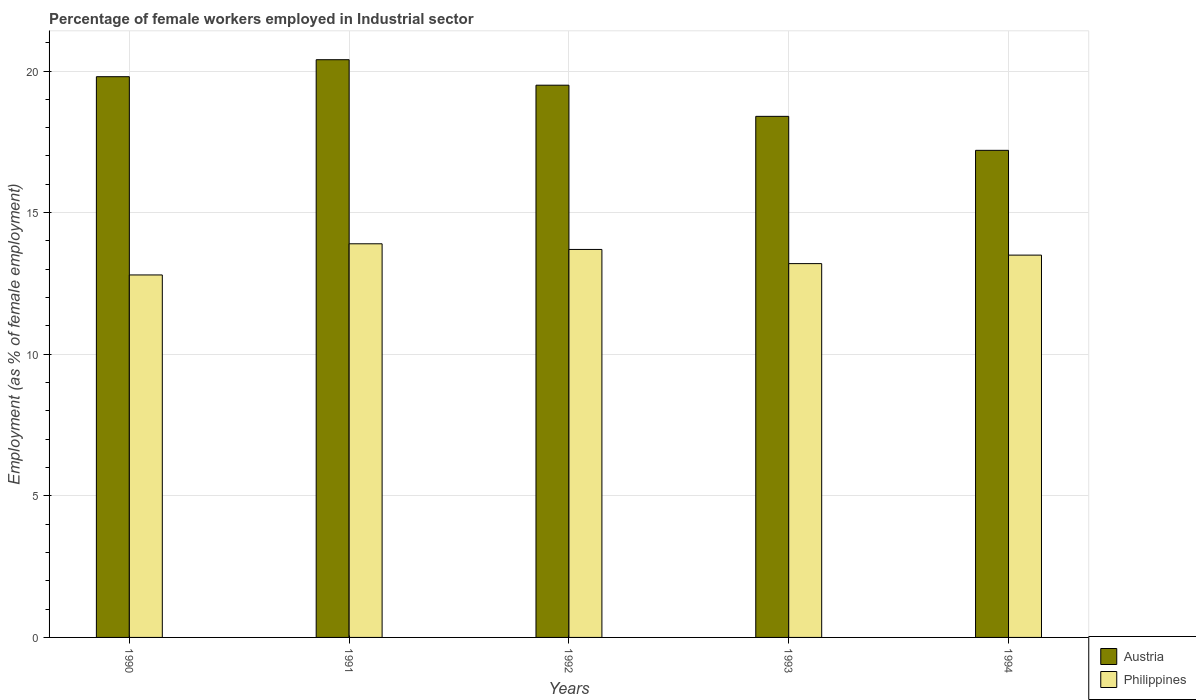How many groups of bars are there?
Make the answer very short. 5. Are the number of bars per tick equal to the number of legend labels?
Provide a succinct answer. Yes. How many bars are there on the 4th tick from the left?
Give a very brief answer. 2. How many bars are there on the 4th tick from the right?
Offer a very short reply. 2. What is the percentage of females employed in Industrial sector in Austria in 1994?
Ensure brevity in your answer.  17.2. Across all years, what is the maximum percentage of females employed in Industrial sector in Philippines?
Keep it short and to the point. 13.9. Across all years, what is the minimum percentage of females employed in Industrial sector in Philippines?
Your answer should be compact. 12.8. In which year was the percentage of females employed in Industrial sector in Philippines minimum?
Your response must be concise. 1990. What is the total percentage of females employed in Industrial sector in Austria in the graph?
Give a very brief answer. 95.3. What is the difference between the percentage of females employed in Industrial sector in Philippines in 1991 and that in 1992?
Keep it short and to the point. 0.2. What is the difference between the percentage of females employed in Industrial sector in Austria in 1993 and the percentage of females employed in Industrial sector in Philippines in 1990?
Make the answer very short. 5.6. What is the average percentage of females employed in Industrial sector in Philippines per year?
Offer a very short reply. 13.42. In the year 1992, what is the difference between the percentage of females employed in Industrial sector in Philippines and percentage of females employed in Industrial sector in Austria?
Give a very brief answer. -5.8. What is the ratio of the percentage of females employed in Industrial sector in Austria in 1991 to that in 1993?
Offer a terse response. 1.11. Is the difference between the percentage of females employed in Industrial sector in Philippines in 1991 and 1994 greater than the difference between the percentage of females employed in Industrial sector in Austria in 1991 and 1994?
Keep it short and to the point. No. What is the difference between the highest and the second highest percentage of females employed in Industrial sector in Austria?
Give a very brief answer. 0.6. What is the difference between the highest and the lowest percentage of females employed in Industrial sector in Austria?
Your answer should be very brief. 3.2. Is the sum of the percentage of females employed in Industrial sector in Austria in 1990 and 1992 greater than the maximum percentage of females employed in Industrial sector in Philippines across all years?
Provide a short and direct response. Yes. How many bars are there?
Provide a short and direct response. 10. Are the values on the major ticks of Y-axis written in scientific E-notation?
Your answer should be very brief. No. How many legend labels are there?
Offer a very short reply. 2. What is the title of the graph?
Provide a short and direct response. Percentage of female workers employed in Industrial sector. What is the label or title of the X-axis?
Your answer should be compact. Years. What is the label or title of the Y-axis?
Your response must be concise. Employment (as % of female employment). What is the Employment (as % of female employment) of Austria in 1990?
Your answer should be very brief. 19.8. What is the Employment (as % of female employment) in Philippines in 1990?
Offer a terse response. 12.8. What is the Employment (as % of female employment) in Austria in 1991?
Your response must be concise. 20.4. What is the Employment (as % of female employment) in Philippines in 1991?
Provide a short and direct response. 13.9. What is the Employment (as % of female employment) of Austria in 1992?
Make the answer very short. 19.5. What is the Employment (as % of female employment) in Philippines in 1992?
Keep it short and to the point. 13.7. What is the Employment (as % of female employment) in Austria in 1993?
Keep it short and to the point. 18.4. What is the Employment (as % of female employment) in Philippines in 1993?
Provide a succinct answer. 13.2. What is the Employment (as % of female employment) of Austria in 1994?
Offer a very short reply. 17.2. What is the Employment (as % of female employment) of Philippines in 1994?
Your response must be concise. 13.5. Across all years, what is the maximum Employment (as % of female employment) of Austria?
Keep it short and to the point. 20.4. Across all years, what is the maximum Employment (as % of female employment) in Philippines?
Your answer should be compact. 13.9. Across all years, what is the minimum Employment (as % of female employment) in Austria?
Your answer should be very brief. 17.2. Across all years, what is the minimum Employment (as % of female employment) of Philippines?
Your answer should be compact. 12.8. What is the total Employment (as % of female employment) of Austria in the graph?
Your answer should be compact. 95.3. What is the total Employment (as % of female employment) in Philippines in the graph?
Provide a succinct answer. 67.1. What is the difference between the Employment (as % of female employment) of Austria in 1990 and that in 1992?
Provide a short and direct response. 0.3. What is the difference between the Employment (as % of female employment) of Philippines in 1990 and that in 1992?
Provide a short and direct response. -0.9. What is the difference between the Employment (as % of female employment) of Austria in 1990 and that in 1993?
Provide a succinct answer. 1.4. What is the difference between the Employment (as % of female employment) in Philippines in 1991 and that in 1992?
Make the answer very short. 0.2. What is the difference between the Employment (as % of female employment) of Austria in 1991 and that in 1993?
Your answer should be very brief. 2. What is the difference between the Employment (as % of female employment) in Philippines in 1991 and that in 1993?
Your response must be concise. 0.7. What is the difference between the Employment (as % of female employment) of Philippines in 1991 and that in 1994?
Your answer should be very brief. 0.4. What is the difference between the Employment (as % of female employment) in Austria in 1992 and that in 1994?
Offer a very short reply. 2.3. What is the difference between the Employment (as % of female employment) in Austria in 1993 and that in 1994?
Offer a terse response. 1.2. What is the difference between the Employment (as % of female employment) in Austria in 1990 and the Employment (as % of female employment) in Philippines in 1991?
Provide a short and direct response. 5.9. What is the difference between the Employment (as % of female employment) of Austria in 1990 and the Employment (as % of female employment) of Philippines in 1994?
Keep it short and to the point. 6.3. What is the difference between the Employment (as % of female employment) of Austria in 1991 and the Employment (as % of female employment) of Philippines in 1993?
Keep it short and to the point. 7.2. What is the difference between the Employment (as % of female employment) in Austria in 1991 and the Employment (as % of female employment) in Philippines in 1994?
Your answer should be compact. 6.9. What is the difference between the Employment (as % of female employment) in Austria in 1992 and the Employment (as % of female employment) in Philippines in 1994?
Offer a terse response. 6. What is the difference between the Employment (as % of female employment) in Austria in 1993 and the Employment (as % of female employment) in Philippines in 1994?
Give a very brief answer. 4.9. What is the average Employment (as % of female employment) in Austria per year?
Offer a very short reply. 19.06. What is the average Employment (as % of female employment) in Philippines per year?
Your response must be concise. 13.42. In the year 1990, what is the difference between the Employment (as % of female employment) in Austria and Employment (as % of female employment) in Philippines?
Keep it short and to the point. 7. In the year 1991, what is the difference between the Employment (as % of female employment) in Austria and Employment (as % of female employment) in Philippines?
Ensure brevity in your answer.  6.5. In the year 1992, what is the difference between the Employment (as % of female employment) of Austria and Employment (as % of female employment) of Philippines?
Your answer should be very brief. 5.8. What is the ratio of the Employment (as % of female employment) in Austria in 1990 to that in 1991?
Your answer should be very brief. 0.97. What is the ratio of the Employment (as % of female employment) in Philippines in 1990 to that in 1991?
Keep it short and to the point. 0.92. What is the ratio of the Employment (as % of female employment) in Austria in 1990 to that in 1992?
Provide a short and direct response. 1.02. What is the ratio of the Employment (as % of female employment) of Philippines in 1990 to that in 1992?
Your answer should be compact. 0.93. What is the ratio of the Employment (as % of female employment) in Austria in 1990 to that in 1993?
Provide a succinct answer. 1.08. What is the ratio of the Employment (as % of female employment) of Philippines in 1990 to that in 1993?
Provide a succinct answer. 0.97. What is the ratio of the Employment (as % of female employment) in Austria in 1990 to that in 1994?
Your answer should be compact. 1.15. What is the ratio of the Employment (as % of female employment) of Philippines in 1990 to that in 1994?
Provide a succinct answer. 0.95. What is the ratio of the Employment (as % of female employment) of Austria in 1991 to that in 1992?
Your answer should be very brief. 1.05. What is the ratio of the Employment (as % of female employment) in Philippines in 1991 to that in 1992?
Offer a terse response. 1.01. What is the ratio of the Employment (as % of female employment) in Austria in 1991 to that in 1993?
Give a very brief answer. 1.11. What is the ratio of the Employment (as % of female employment) in Philippines in 1991 to that in 1993?
Ensure brevity in your answer.  1.05. What is the ratio of the Employment (as % of female employment) of Austria in 1991 to that in 1994?
Offer a very short reply. 1.19. What is the ratio of the Employment (as % of female employment) in Philippines in 1991 to that in 1994?
Provide a short and direct response. 1.03. What is the ratio of the Employment (as % of female employment) of Austria in 1992 to that in 1993?
Provide a succinct answer. 1.06. What is the ratio of the Employment (as % of female employment) in Philippines in 1992 to that in 1993?
Give a very brief answer. 1.04. What is the ratio of the Employment (as % of female employment) in Austria in 1992 to that in 1994?
Your answer should be very brief. 1.13. What is the ratio of the Employment (as % of female employment) in Philippines in 1992 to that in 1994?
Provide a short and direct response. 1.01. What is the ratio of the Employment (as % of female employment) in Austria in 1993 to that in 1994?
Provide a short and direct response. 1.07. What is the ratio of the Employment (as % of female employment) of Philippines in 1993 to that in 1994?
Provide a short and direct response. 0.98. What is the difference between the highest and the lowest Employment (as % of female employment) in Philippines?
Offer a very short reply. 1.1. 